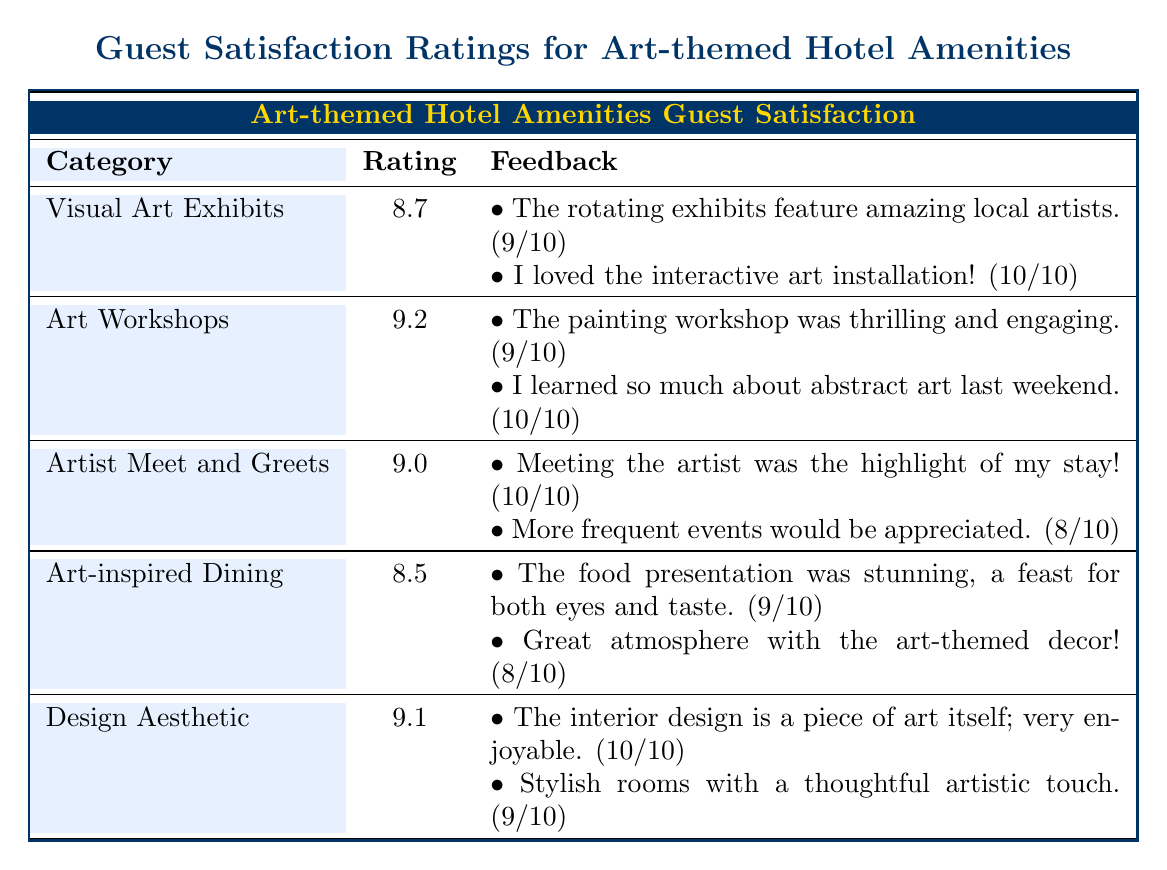What is the highest guest satisfaction rating among the amenities? The table lists the guest satisfaction ratings for various amenities. Scanning through the ratings, the highest value is 9.2 from the "Art Workshops" category.
Answer: 9.2 What is the satisfaction rating for "Art-inspired Dining"? Directly from the table, the guest satisfaction rating for "Art-inspired Dining" is 8.5.
Answer: 8.5 How many amenities have a satisfaction rating above 9? By examining the ratings, we find that "Art Workshops" (9.2) and "Artist Meet and Greets" (9.0) are above 9. Therefore, there are two amenities surpassing that threshold.
Answer: 2 Is the feedback for "Visual Art Exhibits" rated lower than that for "Design Aesthetic"? For "Visual Art Exhibits", the guest satisfaction rating is 8.7, while for "Design Aesthetic," it is 9.1. Since 8.7 is lower than 9.1, the statement is true.
Answer: Yes What is the average guest satisfaction rating across all amenities? To find the average, we add the ratings: (8.7 + 9.2 + 9.0 + 8.5 + 9.1) = 44.5. There are 5 amenities, so the average is 44.5 / 5 = 8.9.
Answer: 8.9 Which feedback comment has the highest rating, and what is its value? The feedback comments associated with their ratings show that "I loved the interactive art installation!" is rated 10. This is the highest rating present in the feedback.
Answer: 10 Is "Artist Meet and Greets" rated higher than "Art-inspired Dining"? The ratings are 9.0 for "Artist Meet and Greets" and 8.5 for "Art-inspired Dining." Thus, 9.0 is greater than 8.5, confirming that "Artist Meet and Greets" has a higher rating.
Answer: Yes What is the median guest satisfaction rating from the amenities listed? The ratings in ascending order are: 8.5, 8.7, 9.0, 9.1, 9.2. Since there are five ratings, the median is the middle value, which is 9.0.
Answer: 9.0 What percentage of the amenities have a guest satisfaction rating below 9? From the data, three amenities have ratings below 9: "Visual Art Exhibits" (8.7), "Art-inspired Dining" (8.5), and "Design Aesthetic" (which is not below 9). Since we have 5 total amenities, the percentage is (3 / 5) * 100 = 60%.
Answer: 60% 